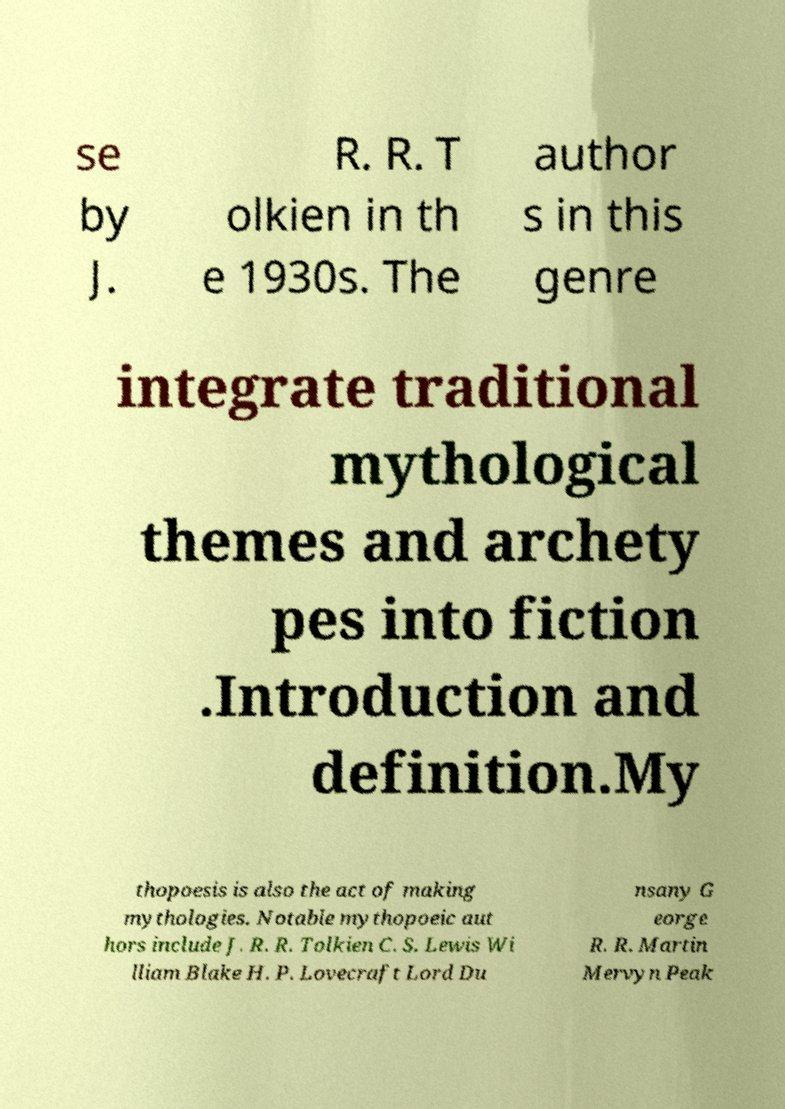Please identify and transcribe the text found in this image. se by J. R. R. T olkien in th e 1930s. The author s in this genre integrate traditional mythological themes and archety pes into fiction .Introduction and definition.My thopoesis is also the act of making mythologies. Notable mythopoeic aut hors include J. R. R. Tolkien C. S. Lewis Wi lliam Blake H. P. Lovecraft Lord Du nsany G eorge R. R. Martin Mervyn Peak 